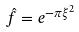<formula> <loc_0><loc_0><loc_500><loc_500>\hat { f } = e ^ { - \pi \xi ^ { 2 } }</formula> 